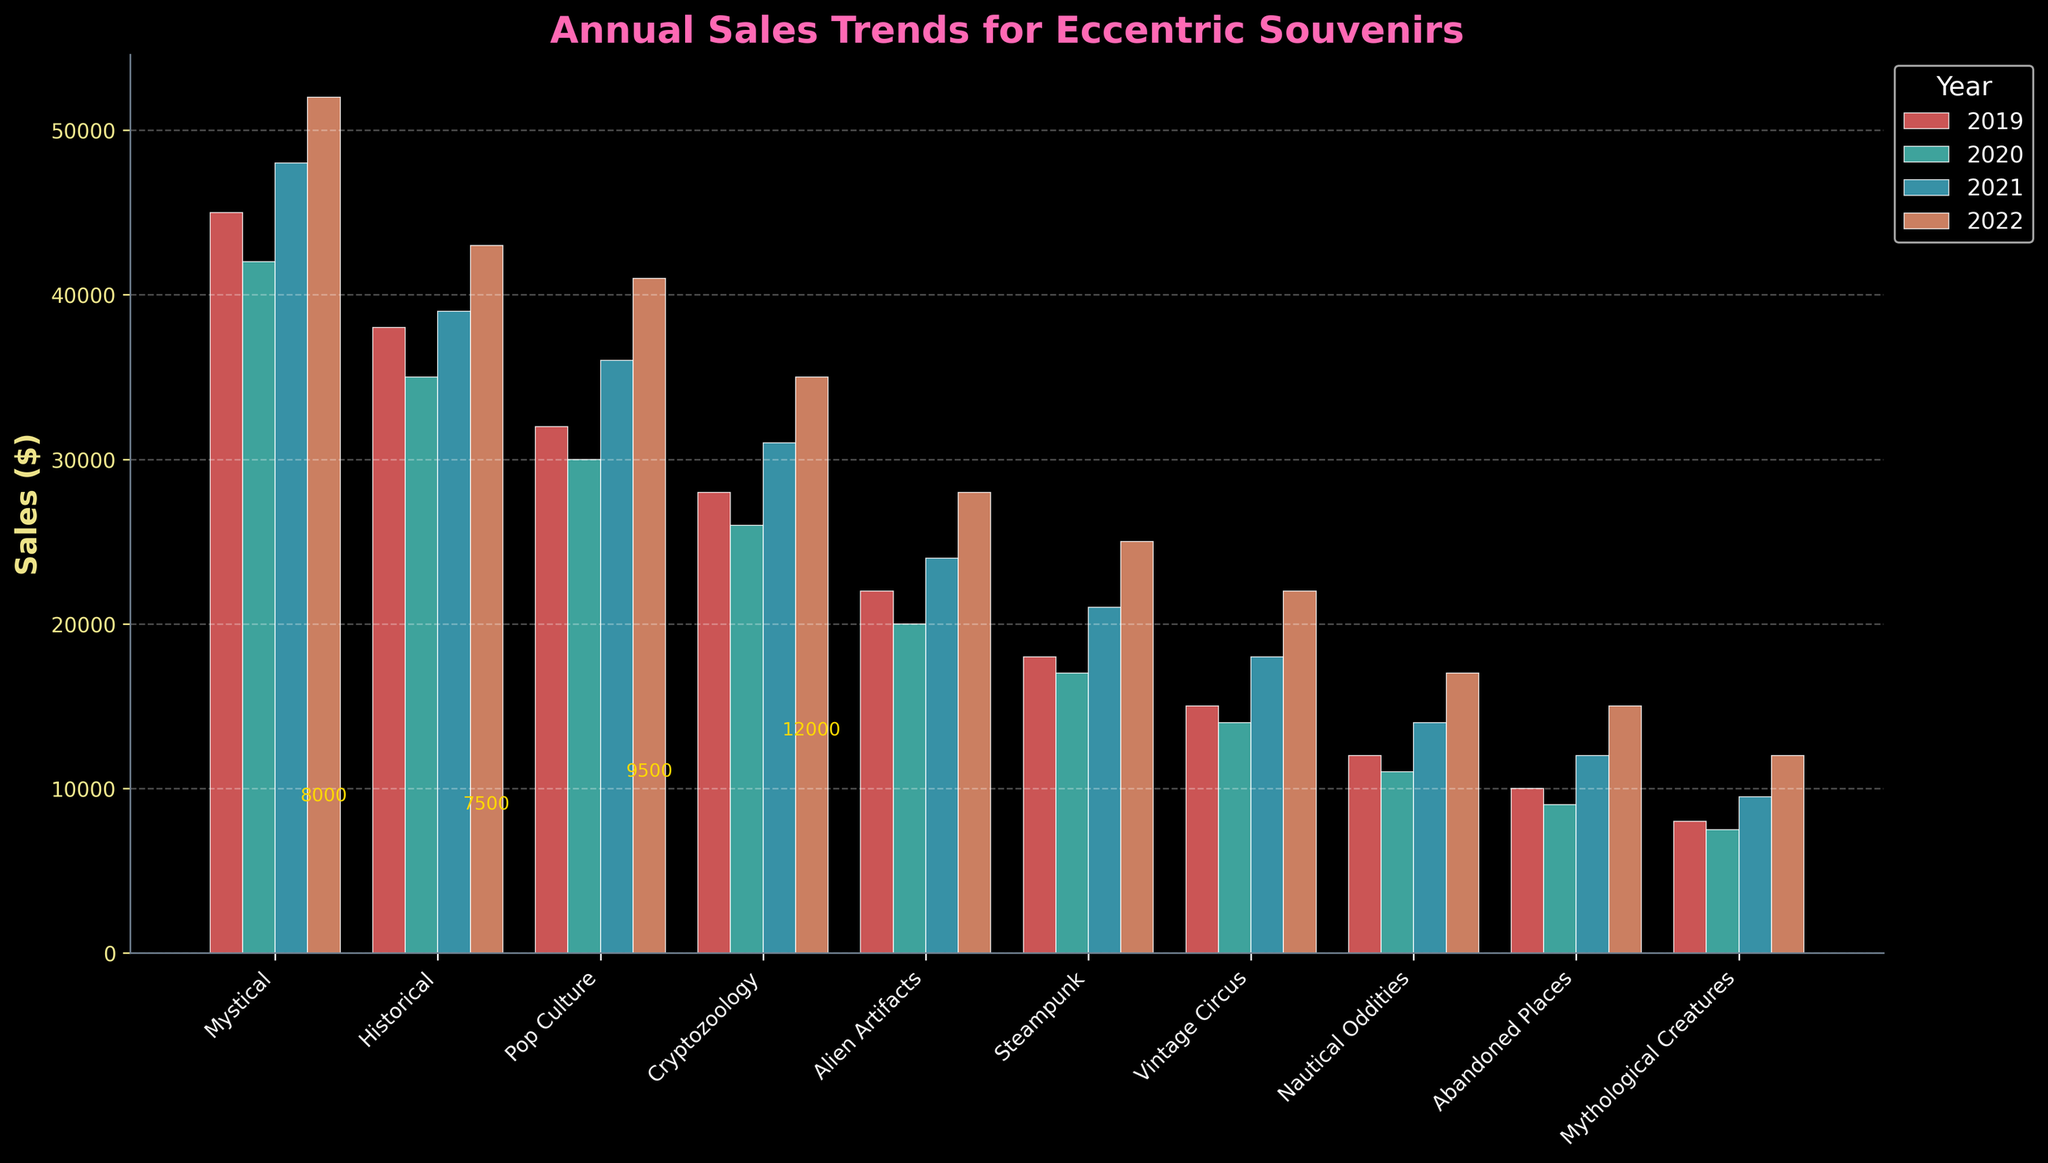Which theme had the highest sales in 2022? Look at the highest bar among the themes for the year 2022. "Mystical" has the highest bar.
Answer: Mystical How did the sales of "Historical" items change from 2019 to 2022? Note the sales figures for "Historical" and observe the increase or decrease from year to year: 38000 (2019), 35000 (2020), 39000 (2021), and 43000 (2022). The sales show a decrease from 2019 to 2020, then an increase in subsequent years.
Answer: Increased overall Compare the sales growth between "Alien Artifacts" and "Steampunk" from 2019 to 2022. Which theme had a higher growth rate? Find the difference in sales from 2019 to 2022 for both themes:
"Alien Artifacts": 28000 - 22000 = 6000
"Steampunk": 25000 - 18000 = 7000
"Steampunk" has a higher growth rate.
Answer: Steampunk Which year had the lowest overall sales for all themes combined? Sum the sales of all themes for each year:
2019: 45000 + 38000 + 32000 + 28000 + 22000 + 18000 + 15000 + 12000 + 10000 + 8000 = 238000
2020: 42000 + 35000 + 30000 + 26000 + 20000 + 17000 + 14000 + 11000 + 9000 + 7500 = 212500
2021: 48000 + 39000 + 36000 + 31000 + 24000 + 21000 + 18000 + 14000 + 12000 + 9500 = 252500
2022: 52000 + 43000 + 41000 + 35000 + 28000 + 25000 + 22000 + 17000 + 15000 + 12000 = 292000
2020 has the lowest overall sales.
Answer: 2020 What is the sum of sales for "Steampunk" and "Vintage Circus" in 2021? Add the sales values for both themes in the year 2021: 21000 (Steampunk) + 18000 (Vintage Circus) = 39000
Answer: 39000 How do the lengths of the bars for "Pop Culture" in different years compare visually? Observe the bar heights for "Pop Culture" from 2019 to 2022. The heights increase each year, indicating an upward trend.
Answer: Increasing trend For which theme did sales increase the most from 2021 to 2022? Calculate the increase in sales for each theme from 2021 to 2022 and identify the theme with the largest increase:
Mystical: 52000 - 48000 = 4000
Historical: 43000 - 39000 = 4000
Pop Culture: 41000 - 36000 = 5000
Cryptozoology: 35000 - 31000 = 4000
Alien Artifacts: 28000 - 24000 = 4000
Steampunk: 25000 - 21000 = 4000
Vintage Circus: 22000 - 18000 = 4000
Nautical Oddities: 17000 - 14000 = 3000
Abandoned Places: 15000 - 12000 = 3000
Mythological Creatures: 12000 - 9500 = 2500
"Pop Culture" had the largest increase.
Answer: Pop Culture Which theme consistently had the lowest sales from 2019 to 2022? Identify the theme with the lowest sales figure consistently over the years. "Mythological Creatures" maintains the lowest sales each year.
Answer: Mythological Creatures By how much did "Nautical Oddities" sales increase from 2020 to 2022? Calculate the difference between the sales in 2020 and 2022: 17000 (2022) - 11000 (2020) = 6000
Answer: 6000 